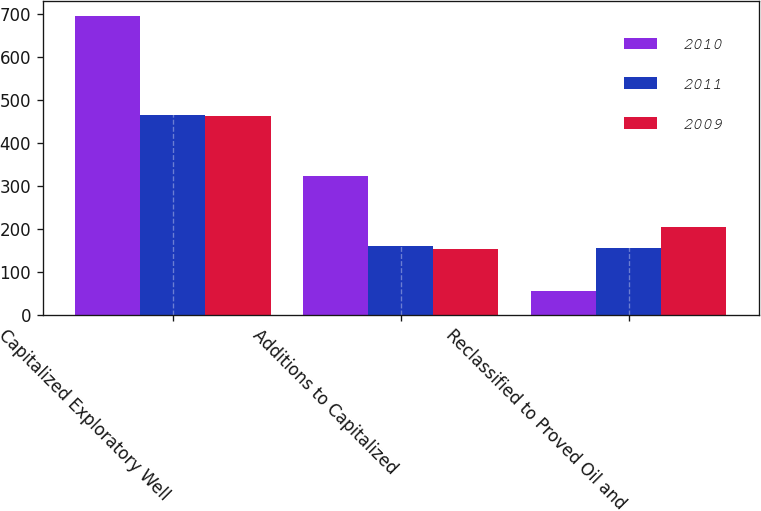<chart> <loc_0><loc_0><loc_500><loc_500><stacked_bar_chart><ecel><fcel>Capitalized Exploratory Well<fcel>Additions to Capitalized<fcel>Reclassified to Proved Oil and<nl><fcel>2010<fcel>696<fcel>322<fcel>55<nl><fcel>2011<fcel>466<fcel>161<fcel>155<nl><fcel>2009<fcel>463<fcel>153<fcel>205<nl></chart> 